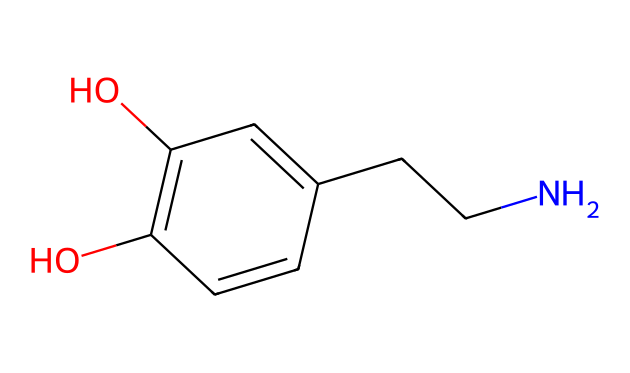What is the molecular formula of dopamine based on its structure? The molecular formula can be derived by counting the number of each type of atom in the SMILES representation. There are 8 carbon atoms (C), 11 hydrogen atoms (H), 2 nitrogen atoms (N), and 2 oxygen atoms (O). Therefore, the molecular formula is C8H11N2O2.
Answer: C8H11N2O2 How many hydroxyl (–OH) groups are present in this compound? In the chemical structure, hydroxyl groups are indicated by the presence of oxygen atoms bonded to hydrogen atoms (–OH). The structure displays two –OH groups, indicating that there are two hydroxyl groups.
Answer: 2 What type of functional groups can be identified in this structure? By analyzing the structure, we see the presence of phenolic –OH groups and alkyl amine (due to the presence of the nitrogen connected to the carbon chain). These functional groups are indicative of its properties as a neurotransmitter.
Answer: phenolic and amine Is this compound aromatic? The presence of a benzene ring in the structure, which is a six-membered carbon ring with alternating double bonds, confirms that the compound is aromatic.
Answer: yes What is the significance of the nitrogen atom(s) in this compound? Nitrogen atoms typically play a crucial role in neurotransmitter function as they can engage in hydrogen bonding and are involved in the molecular interactions that affect the activity of neurotransmitters, such as dopamine.
Answer: neurotransmitter activity Which atom in dopamine can form hydrogen bonds? The hydrogen atoms attached to the nitrogen (and to the hydroxyl oxygen) can form hydrogen bonds due to their capacity to interact with electronegative atoms like oxygen and nitrogen in other molecules.
Answer: nitrogen and oxygen 